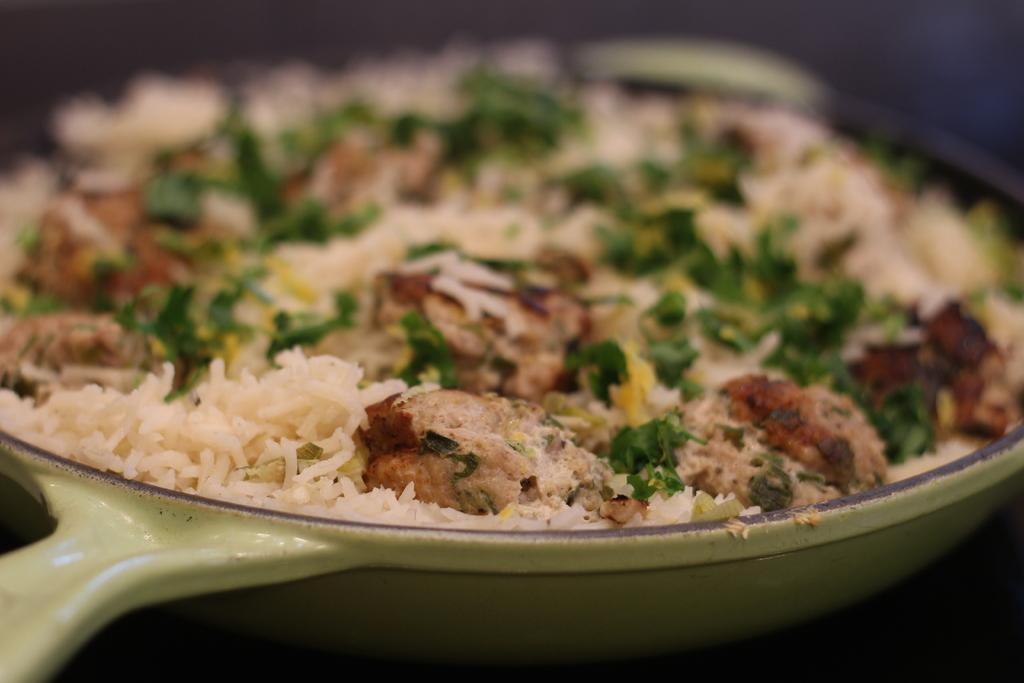What can be seen in the image? There is a pan in the image. What is inside the pan? There are food items in the pan. What type of skirt is being used to stir the food in the pan? There is no skirt present in the image, nor is there any indication that the food is being stirred. 